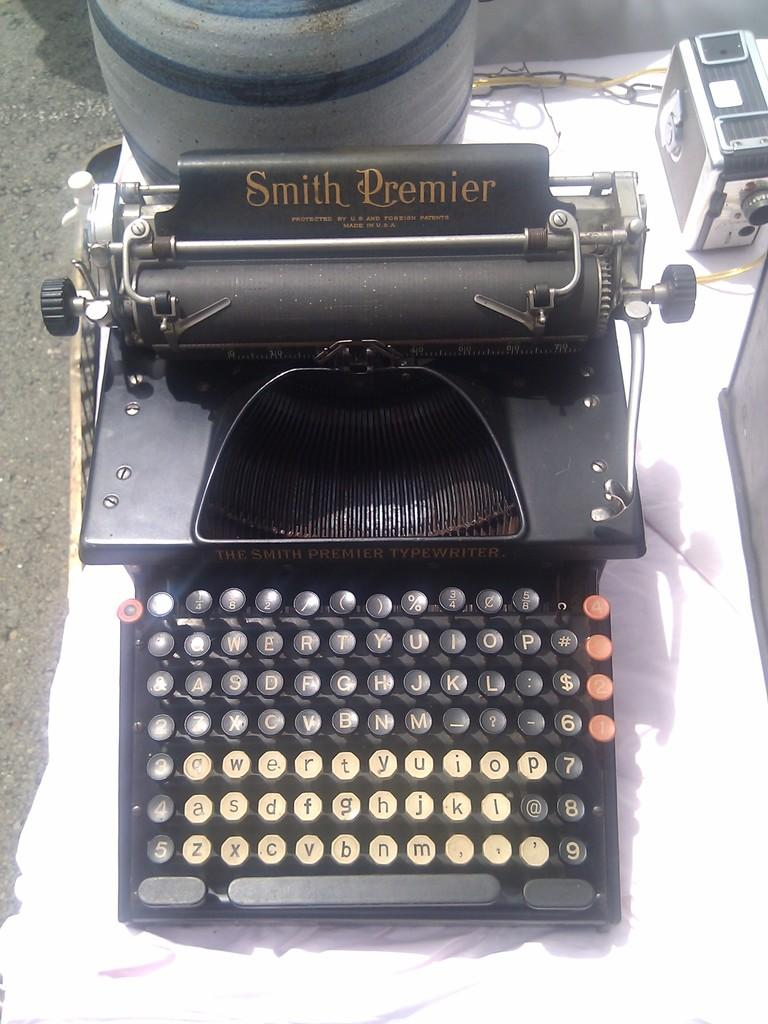What is the main object in the image? There is a typewriter in the image. What is the typewriter placed on? The typewriter is on a white cloth. Can you describe any other objects visible in the image? Unfortunately, the provided facts do not mention any other objects at the top side of the image. Are there any police officers visible in the image? There is no mention of police officers in the provided facts, and therefore, we cannot determine if any are present in the image. 